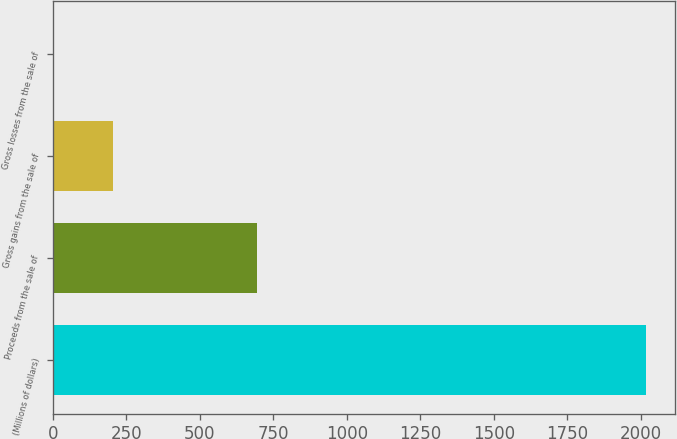Convert chart to OTSL. <chart><loc_0><loc_0><loc_500><loc_500><bar_chart><fcel>(Millions of dollars)<fcel>Proceeds from the sale of<fcel>Gross gains from the sale of<fcel>Gross losses from the sale of<nl><fcel>2016<fcel>694<fcel>205.2<fcel>4<nl></chart> 